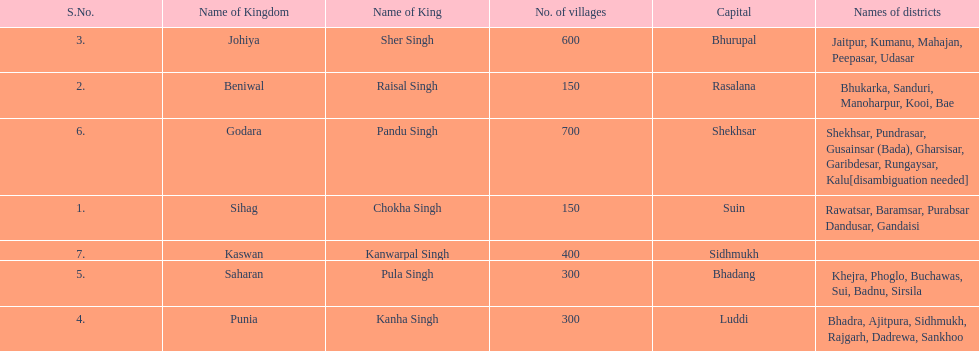Would you mind parsing the complete table? {'header': ['S.No.', 'Name of Kingdom', 'Name of King', 'No. of villages', 'Capital', 'Names of districts'], 'rows': [['3.', 'Johiya', 'Sher Singh', '600', 'Bhurupal', 'Jaitpur, Kumanu, Mahajan, Peepasar, Udasar'], ['2.', 'Beniwal', 'Raisal Singh', '150', 'Rasalana', 'Bhukarka, Sanduri, Manoharpur, Kooi, Bae'], ['6.', 'Godara', 'Pandu Singh', '700', 'Shekhsar', 'Shekhsar, Pundrasar, Gusainsar (Bada), Gharsisar, Garibdesar, Rungaysar, Kalu[disambiguation needed]'], ['1.', 'Sihag', 'Chokha Singh', '150', 'Suin', 'Rawatsar, Baramsar, Purabsar Dandusar, Gandaisi'], ['7.', 'Kaswan', 'Kanwarpal Singh', '400', 'Sidhmukh', ''], ['5.', 'Saharan', 'Pula Singh', '300', 'Bhadang', 'Khejra, Phoglo, Buchawas, Sui, Badnu, Sirsila'], ['4.', 'Punia', 'Kanha Singh', '300', 'Luddi', 'Bhadra, Ajitpura, Sidhmukh, Rajgarh, Dadrewa, Sankhoo']]} What are the number of villages johiya has according to this chart? 600. 